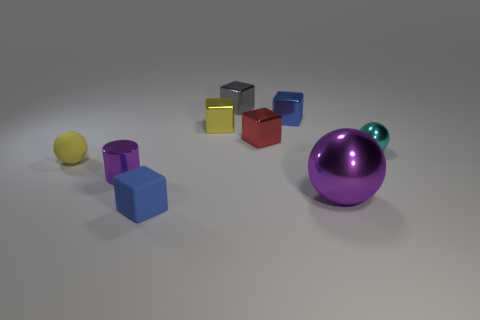There is a small cylinder that is the same color as the big metal object; what is its material?
Keep it short and to the point. Metal. Does the blue cube that is on the right side of the yellow block have the same size as the metal thing that is to the left of the tiny matte block?
Give a very brief answer. Yes. What number of red things are either tiny metal things or tiny objects?
Offer a very short reply. 1. There is a object that is the same color as the small rubber sphere; what size is it?
Your response must be concise. Small. Are there more yellow metal blocks than large cyan rubber blocks?
Provide a succinct answer. Yes. Is the cylinder the same color as the big metal sphere?
Give a very brief answer. Yes. How many objects are either tiny green metallic objects or red metal blocks that are on the right side of the small metallic cylinder?
Your answer should be very brief. 1. What number of other things are the same shape as the small red metallic thing?
Your response must be concise. 4. Are there fewer small spheres that are behind the tiny gray block than blue metallic cubes that are right of the blue metal block?
Ensure brevity in your answer.  No. Are there any other things that are the same material as the small purple cylinder?
Offer a very short reply. Yes. 